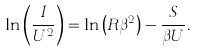Convert formula to latex. <formula><loc_0><loc_0><loc_500><loc_500>\ln \left ( \frac { I } { U ^ { 2 } } \right ) = \ln \left ( R \beta ^ { 2 } \right ) - \frac { S } { \beta U } .</formula> 